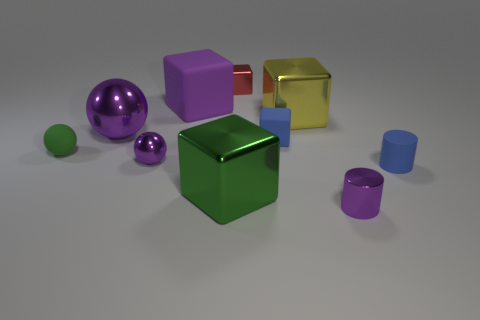Subtract all big blocks. How many blocks are left? 2 Subtract 2 blocks. How many blocks are left? 3 Subtract all cylinders. How many objects are left? 8 Subtract all brown cylinders. How many purple blocks are left? 1 Subtract all blue rubber cylinders. Subtract all big cubes. How many objects are left? 6 Add 8 purple cubes. How many purple cubes are left? 9 Add 2 tiny green metallic blocks. How many tiny green metallic blocks exist? 2 Subtract all blue cubes. How many cubes are left? 4 Subtract 0 yellow cylinders. How many objects are left? 10 Subtract all brown cylinders. Subtract all red cubes. How many cylinders are left? 2 